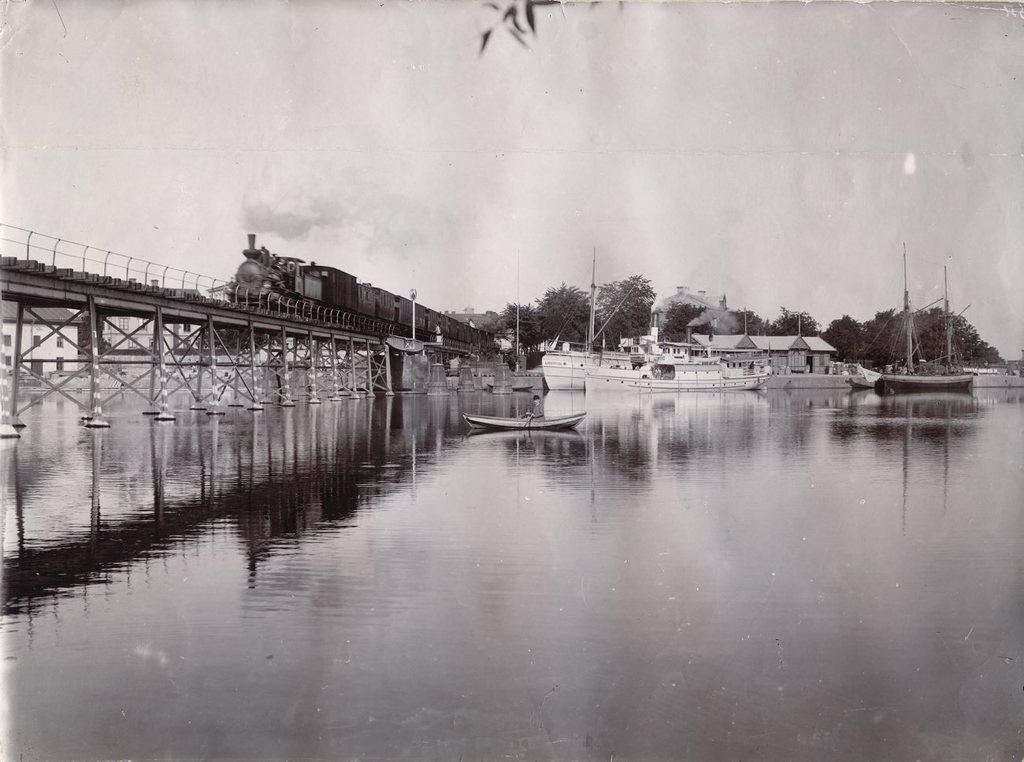What is the color scheme of the image? The image is black and white. What can be seen on the left side of the image? There is a train on a bridge on the left side of the image. What is visible in the background of the image? In the background of the image, there are boats in the water, buildings, poles, windows, trees, and the sky. Can you see a crown on the train in the image? There is no crown visible on the train in the image. What idea does the train represent in the image? The image does not convey any specific ideas or concepts; it simply depicts a train on a bridge and various elements in the background. 